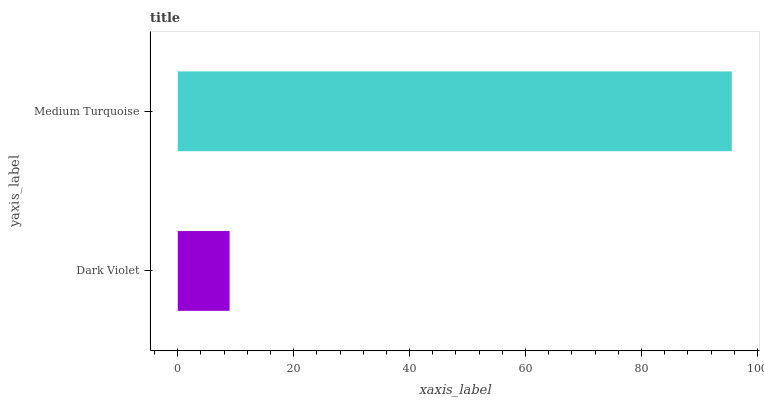Is Dark Violet the minimum?
Answer yes or no. Yes. Is Medium Turquoise the maximum?
Answer yes or no. Yes. Is Medium Turquoise the minimum?
Answer yes or no. No. Is Medium Turquoise greater than Dark Violet?
Answer yes or no. Yes. Is Dark Violet less than Medium Turquoise?
Answer yes or no. Yes. Is Dark Violet greater than Medium Turquoise?
Answer yes or no. No. Is Medium Turquoise less than Dark Violet?
Answer yes or no. No. Is Medium Turquoise the high median?
Answer yes or no. Yes. Is Dark Violet the low median?
Answer yes or no. Yes. Is Dark Violet the high median?
Answer yes or no. No. Is Medium Turquoise the low median?
Answer yes or no. No. 